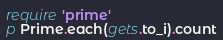Convert code to text. <code><loc_0><loc_0><loc_500><loc_500><_Ruby_>require 'prime'
p Prime.each(gets.to_i).count</code> 